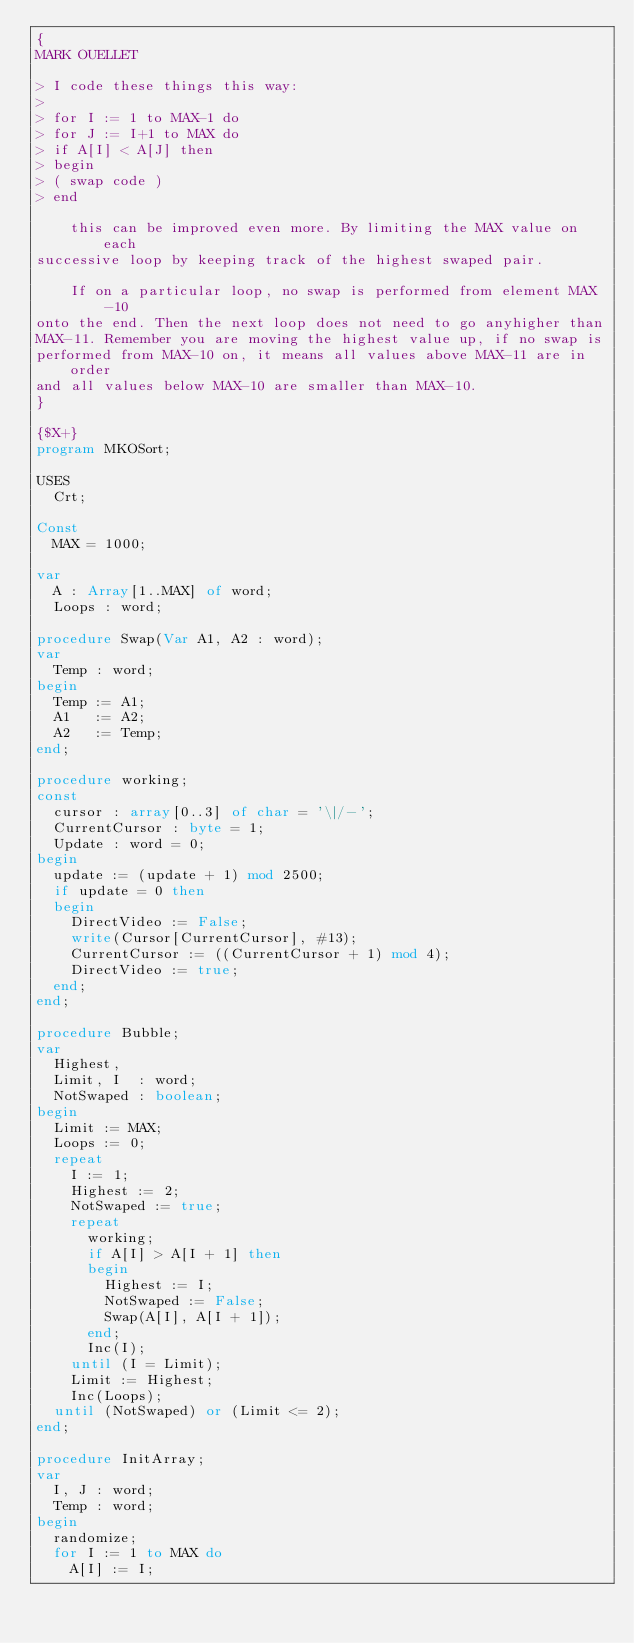Convert code to text. <code><loc_0><loc_0><loc_500><loc_500><_Pascal_>{
MARK OUELLET

> I code these things this way:
>
> for I := 1 to MAX-1 do
> for J := I+1 to MAX do
> if A[I] < A[J] then
> begin
> ( swap code )
> end

    this can be improved even more. By limiting the MAX value on each
successive loop by keeping track of the highest swaped pair.

    If on a particular loop, no swap is performed from element MAX-10
onto the end. Then the next loop does not need to go anyhigher than
MAX-11. Remember you are moving the highest value up, if no swap is
performed from MAX-10 on, it means all values above MAX-11 are in order
and all values below MAX-10 are smaller than MAX-10.
}

{$X+}
program MKOSort;

USES
  Crt;

Const
  MAX = 1000;

var
  A : Array[1..MAX] of word;
  Loops : word;

procedure Swap(Var A1, A2 : word);
var
  Temp : word;
begin
  Temp := A1;
  A1   := A2;
  A2   := Temp;
end;

procedure working;
const
  cursor : array[0..3] of char = '\|/-';
  CurrentCursor : byte = 1;
  Update : word = 0;
begin
  update := (update + 1) mod 2500;
  if update = 0 then
  begin
    DirectVideo := False;
    write(Cursor[CurrentCursor], #13);
    CurrentCursor := ((CurrentCursor + 1) mod 4);
    DirectVideo := true;
  end;
end;

procedure Bubble;
var
  Highest,
  Limit, I  : word;
  NotSwaped : boolean;
begin
  Limit := MAX;
  Loops := 0;
  repeat
    I := 1;
    Highest := 2;
    NotSwaped := true;
    repeat
      working;
      if A[I] > A[I + 1] then
      begin
        Highest := I;
        NotSwaped := False;
        Swap(A[I], A[I + 1]);
      end;
      Inc(I);
    until (I = Limit);
    Limit := Highest;
    Inc(Loops);
  until (NotSwaped) or (Limit <= 2);
end;

procedure InitArray;
var
  I, J : word;
  Temp : word;
begin
  randomize;
  for I := 1 to MAX do
    A[I] := I;</code> 